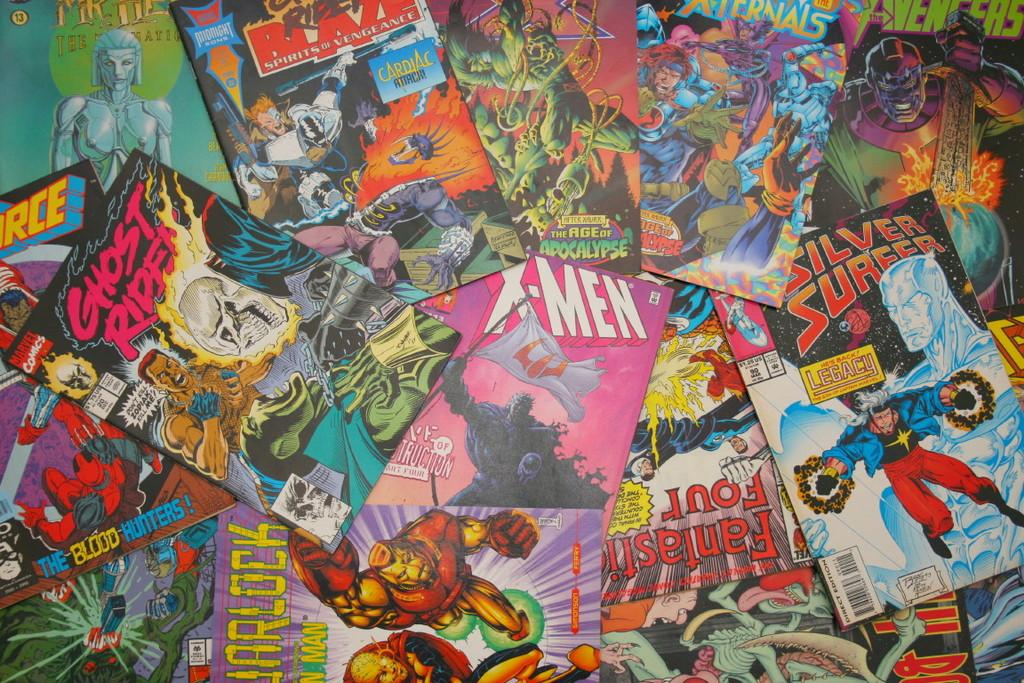<image>
Render a clear and concise summary of the photo. Several comic books such as X-Men, Ghost Rider, and the Silver Surfer in a pile on the floor. 